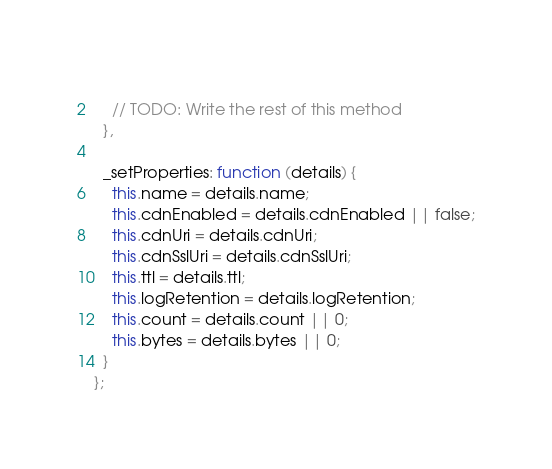Convert code to text. <code><loc_0><loc_0><loc_500><loc_500><_JavaScript_>    
    // TODO: Write the rest of this method
  },
  
  _setProperties: function (details) {
    this.name = details.name;
    this.cdnEnabled = details.cdnEnabled || false;
    this.cdnUri = details.cdnUri;
    this.cdnSslUri = details.cdnSslUri;
    this.ttl = details.ttl;
    this.logRetention = details.logRetention;
    this.count = details.count || 0;
    this.bytes = details.bytes || 0;
  }
};
</code> 